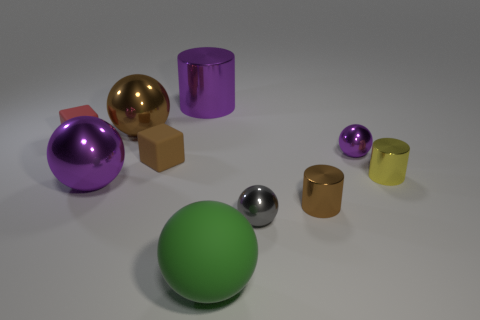There is a tiny thing that is the same color as the large shiny cylinder; what is its material?
Your answer should be very brief. Metal. There is a big cylinder; is it the same color as the tiny ball that is behind the brown matte cube?
Keep it short and to the point. Yes. What color is the large shiny cylinder?
Make the answer very short. Purple. What number of things are either rubber spheres or tiny yellow metallic objects?
Your answer should be very brief. 2. What material is the gray object that is the same size as the red cube?
Your answer should be very brief. Metal. There is a purple thing to the left of the large cylinder; what is its size?
Offer a very short reply. Large. What is the tiny red cube made of?
Make the answer very short. Rubber. What number of objects are tiny metal spheres behind the small gray shiny thing or metallic things that are behind the gray sphere?
Make the answer very short. 6. What number of other objects are the same color as the big metallic cylinder?
Offer a terse response. 2. Does the small brown metallic thing have the same shape as the big object that is in front of the gray thing?
Provide a short and direct response. No. 